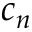Convert formula to latex. <formula><loc_0><loc_0><loc_500><loc_500>c _ { n }</formula> 